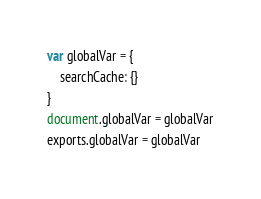<code> <loc_0><loc_0><loc_500><loc_500><_JavaScript_>var globalVar = {
    searchCache: {}
}
document.globalVar = globalVar
exports.globalVar = globalVar</code> 